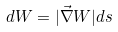<formula> <loc_0><loc_0><loc_500><loc_500>d W = | \vec { \nabla } W | d s</formula> 